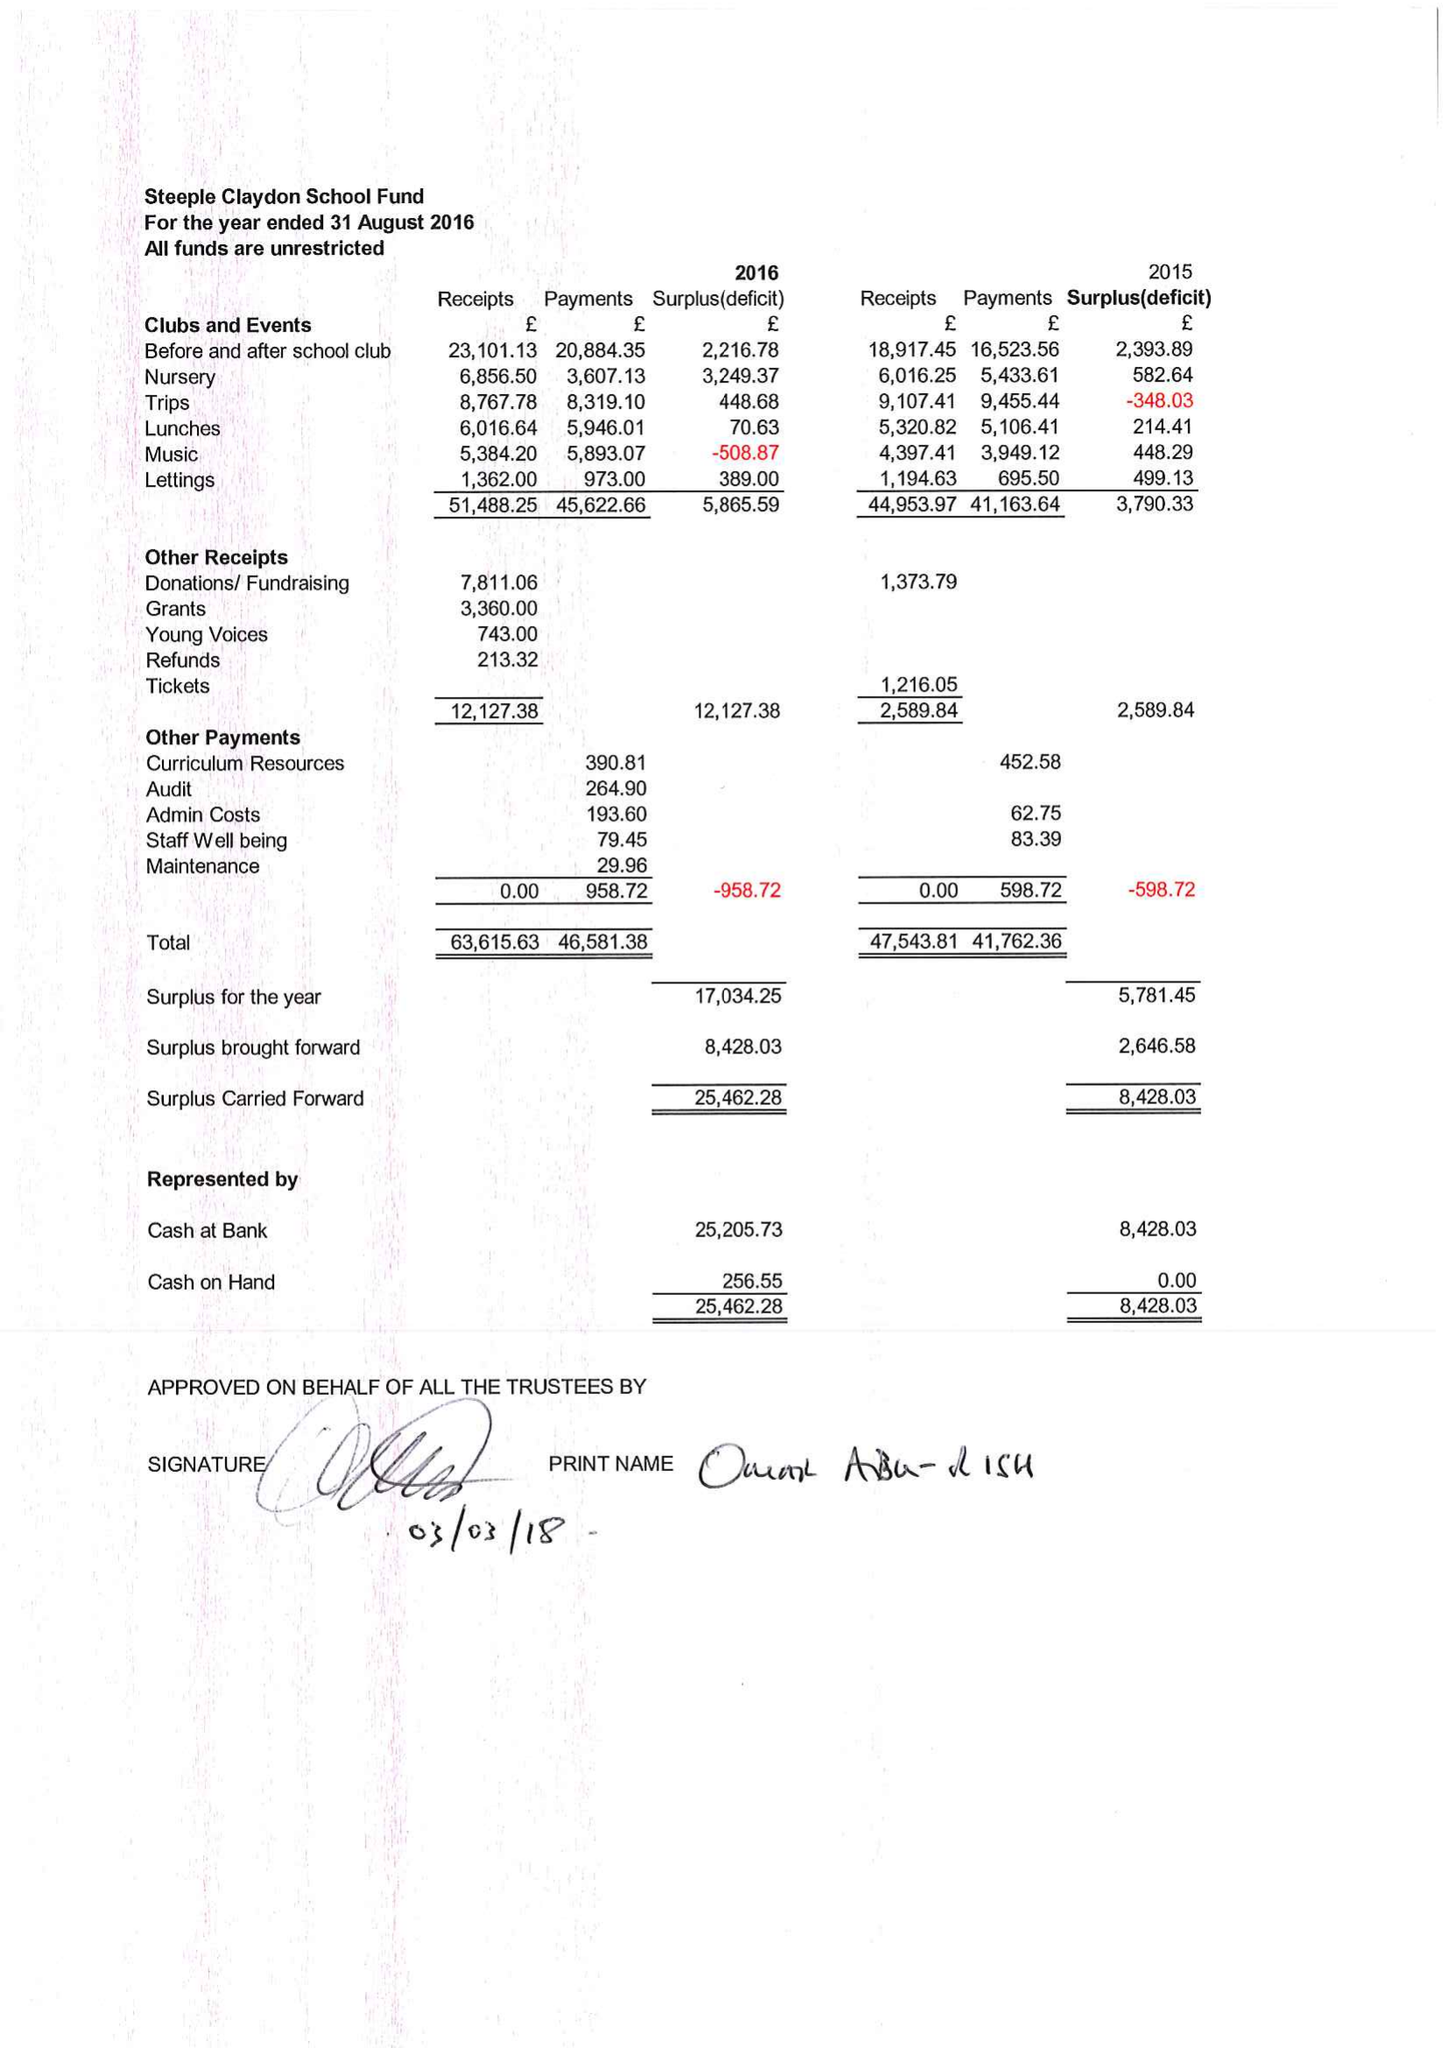What is the value for the charity_name?
Answer the question using a single word or phrase. Steeple Claydon School Fund 